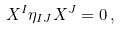Convert formula to latex. <formula><loc_0><loc_0><loc_500><loc_500>X ^ { I } \eta _ { I J } X ^ { J } = 0 \, ,</formula> 